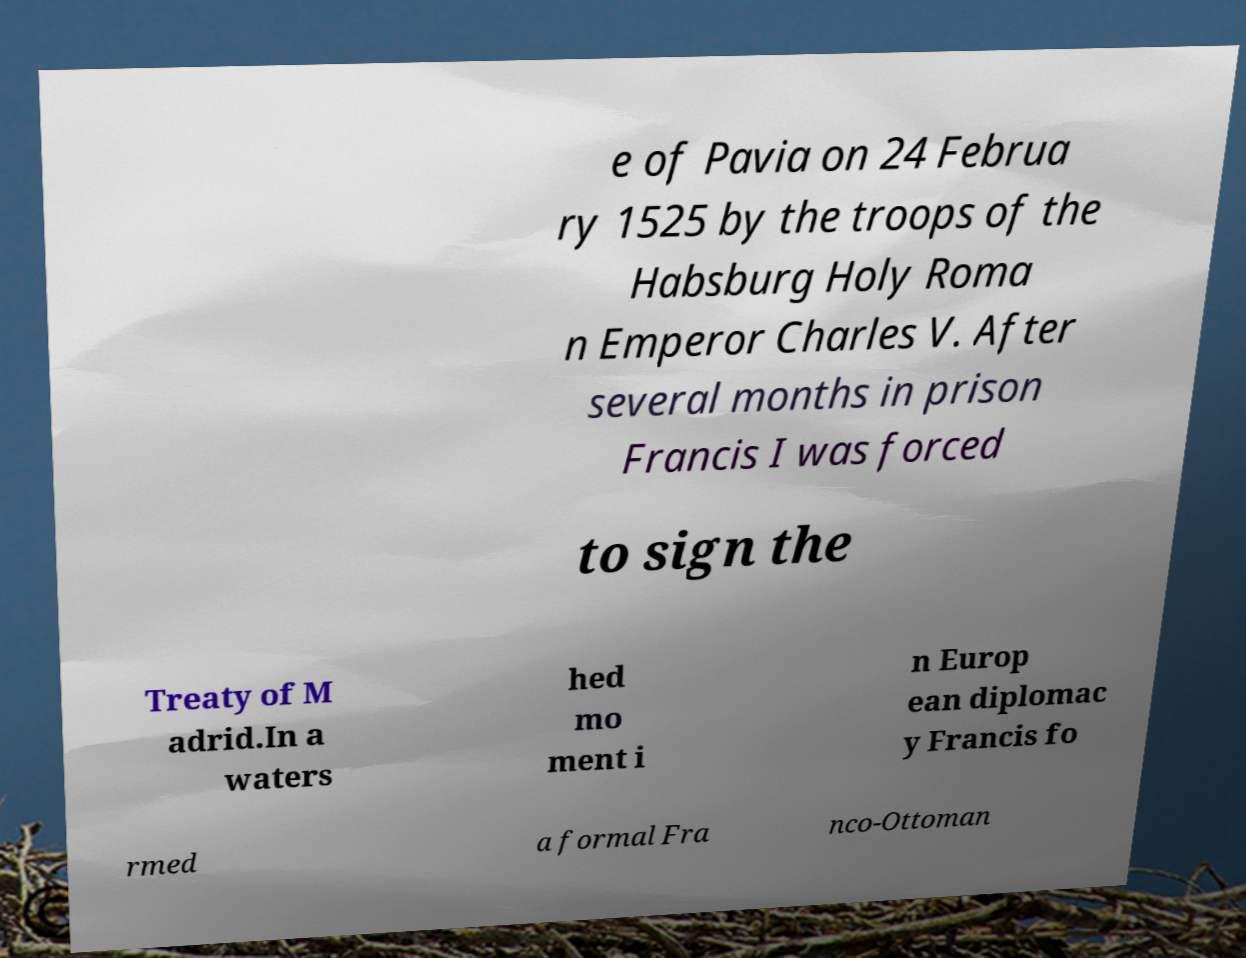Can you accurately transcribe the text from the provided image for me? e of Pavia on 24 Februa ry 1525 by the troops of the Habsburg Holy Roma n Emperor Charles V. After several months in prison Francis I was forced to sign the Treaty of M adrid.In a waters hed mo ment i n Europ ean diplomac y Francis fo rmed a formal Fra nco-Ottoman 